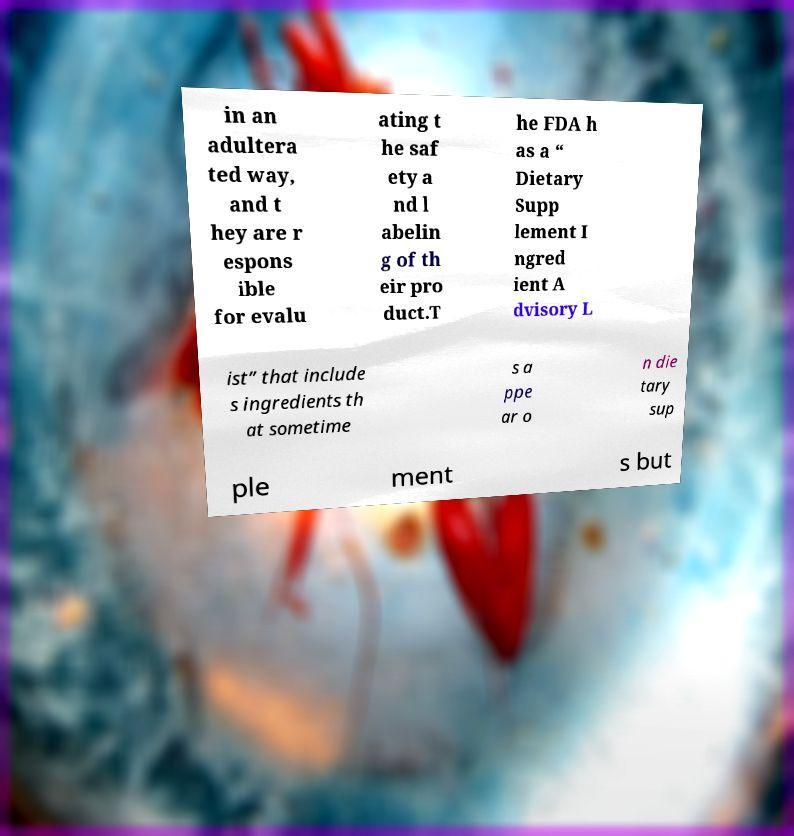Could you extract and type out the text from this image? in an adultera ted way, and t hey are r espons ible for evalu ating t he saf ety a nd l abelin g of th eir pro duct.T he FDA h as a “ Dietary Supp lement I ngred ient A dvisory L ist” that include s ingredients th at sometime s a ppe ar o n die tary sup ple ment s but 